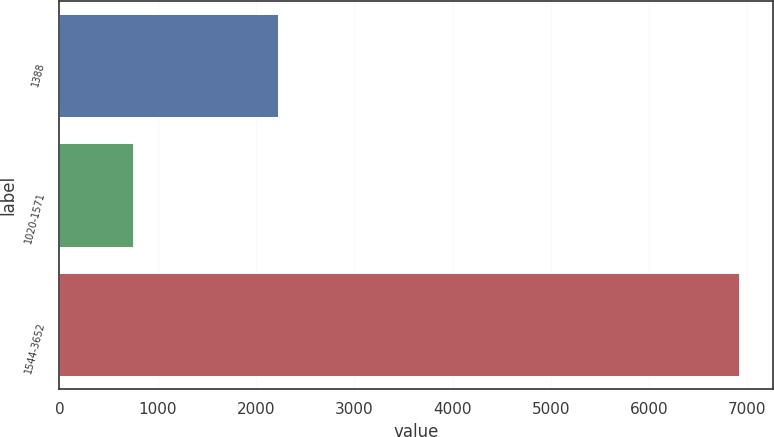Convert chart. <chart><loc_0><loc_0><loc_500><loc_500><bar_chart><fcel>1388<fcel>1020-1571<fcel>1544-3652<nl><fcel>2225<fcel>744<fcel>6914<nl></chart> 